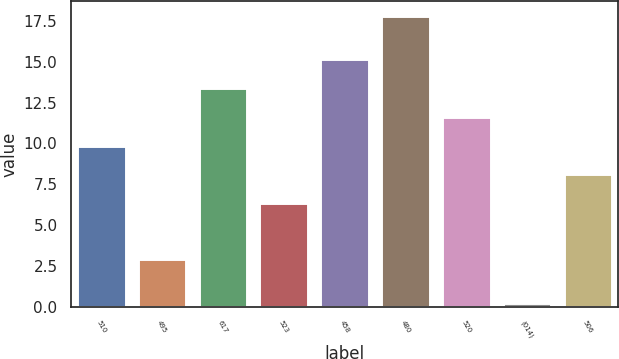<chart> <loc_0><loc_0><loc_500><loc_500><bar_chart><fcel>510<fcel>495<fcel>617<fcel>523<fcel>458<fcel>480<fcel>520<fcel>(014)<fcel>506<nl><fcel>9.87<fcel>2.91<fcel>13.39<fcel>6.35<fcel>15.15<fcel>17.83<fcel>11.63<fcel>0.23<fcel>8.11<nl></chart> 